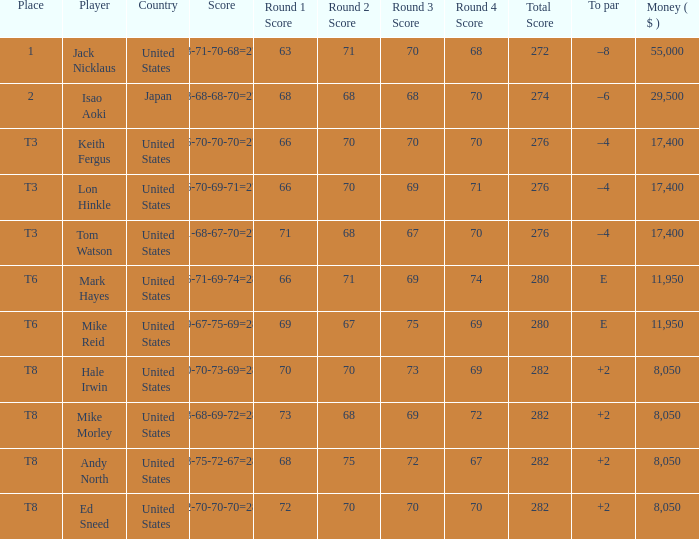What player has money larger than 11,950 and is placed in t8 and has the score of 73-68-69-72=282? None. 